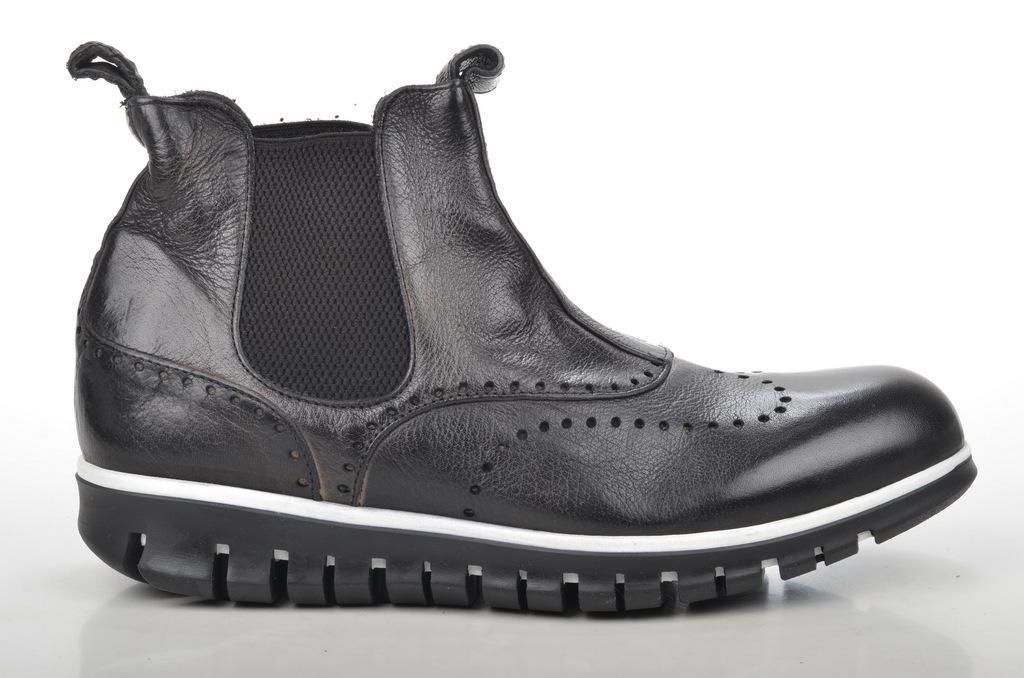How would you summarize this image in a sentence or two? In this image we can see a black color shoe. 